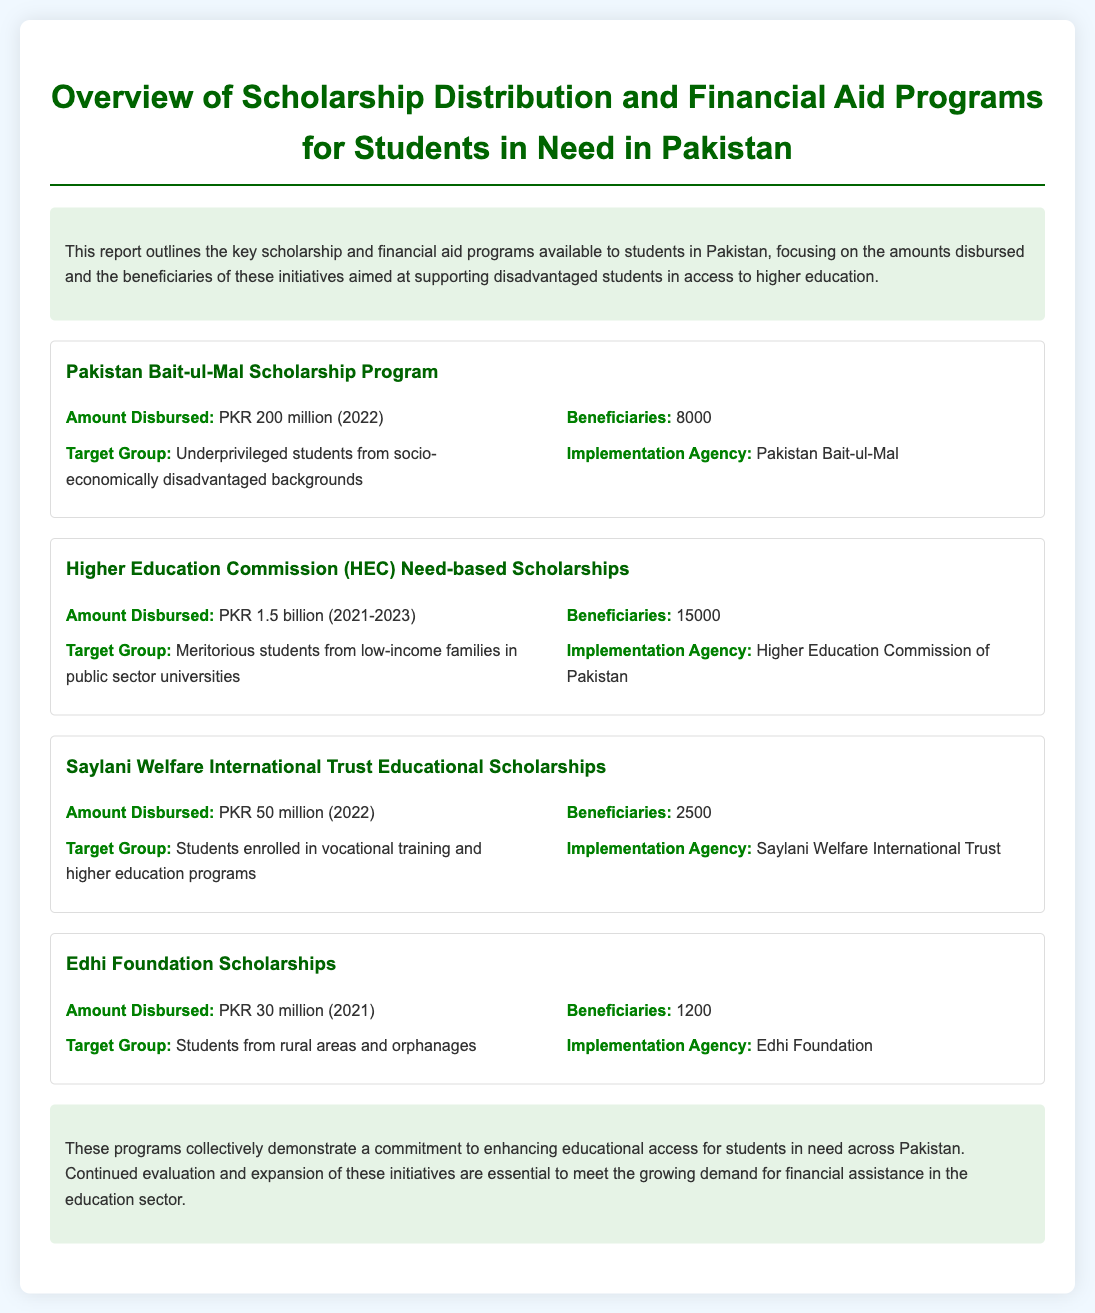What is the total amount disbursed by the Higher Education Commission (HEC) Need-based Scholarships? The total amount disbursed is stated as PKR 1.5 billion for the years 2021-2023.
Answer: PKR 1.5 billion How many beneficiaries received funds from the Pakistan Bait-ul-Mal Scholarship Program? The number of beneficiaries is given as 8000 for the Pakistan Bait-ul-Mal Scholarship Program.
Answer: 8000 What is the target group for the Edhi Foundation Scholarships? The target group is defined as students from rural areas and orphanages according to the document.
Answer: Students from rural areas and orphanages Which organization implemented the Saylani Welfare International Trust Educational Scholarships? The document specifies that the Saylani Welfare International Trust implemented these scholarships.
Answer: Saylani Welfare International Trust What was the amount disbursed by the Edhi Foundation Scholarships in 2021? The report mentions that PKR 30 million was disbursed by the Edhi Foundation Scholarships in 2021.
Answer: PKR 30 million Which scholarship program had the highest number of beneficiaries? The program with the highest number of beneficiaries is the Higher Education Commission (HEC) Need-based Scholarships with 15000 beneficiaries.
Answer: Higher Education Commission (HEC) Need-based Scholarships What is the significance of the scholarship programs mentioned in the conclusion? The conclusion highlights the commitment to enhancing educational access for students in need across Pakistan through these programs.
Answer: Commitment to enhancing educational access Which year shows the disbursement amount for the Saylani Welfare International Trust Scholarships? The document states that PKR 50 million was disbursed in the year 2022 for Saylani Welfare International Trust Scholarships.
Answer: 2022 What is the overall purpose of the report? The report outlines key scholarship and financial aid programs focusing on support for disadvantaged students in higher education.
Answer: Support for disadvantaged students in higher education 